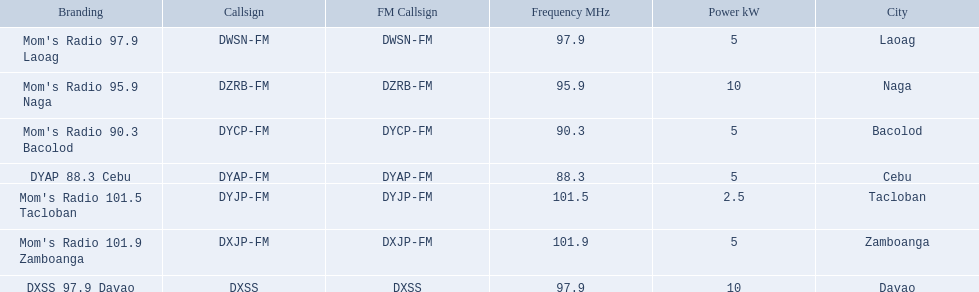Which stations broadcast in dyap-fm? Mom's Radio 97.9 Laoag, Mom's Radio 95.9 Naga, Mom's Radio 90.3 Bacolod, DYAP 88.3 Cebu, Mom's Radio 101.5 Tacloban, Mom's Radio 101.9 Zamboanga, DXSS 97.9 Davao. Of those stations which broadcast in dyap-fm, which stations broadcast with 5kw of power or under? Mom's Radio 97.9 Laoag, Mom's Radio 90.3 Bacolod, DYAP 88.3 Cebu, Mom's Radio 101.5 Tacloban, Mom's Radio 101.9 Zamboanga. Of those stations that broadcast with 5kw of power or under, which broadcasts with the least power? Mom's Radio 101.5 Tacloban. 